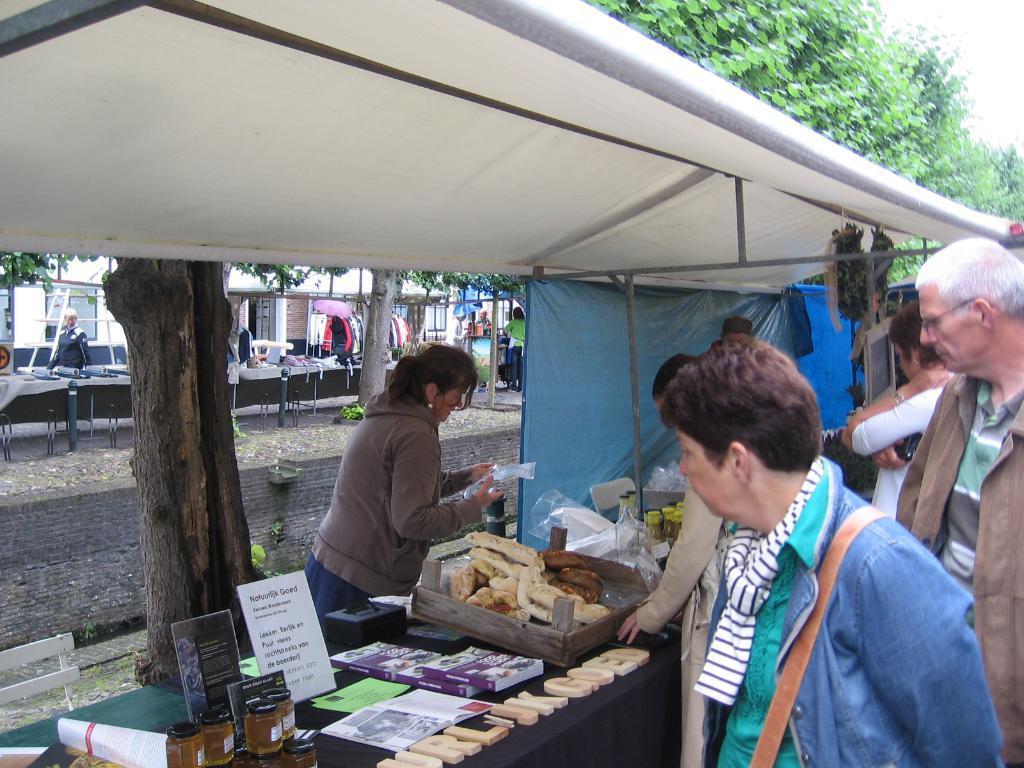How would you summarize this image in a sentence or two? In this image I can see some stalls. In the center of the image a woman is standing in a stall. I can see some objects on the table with labels and some books. I can see a few people standing on the other side of the table. At the top of the image I can see a tree and the sky.  